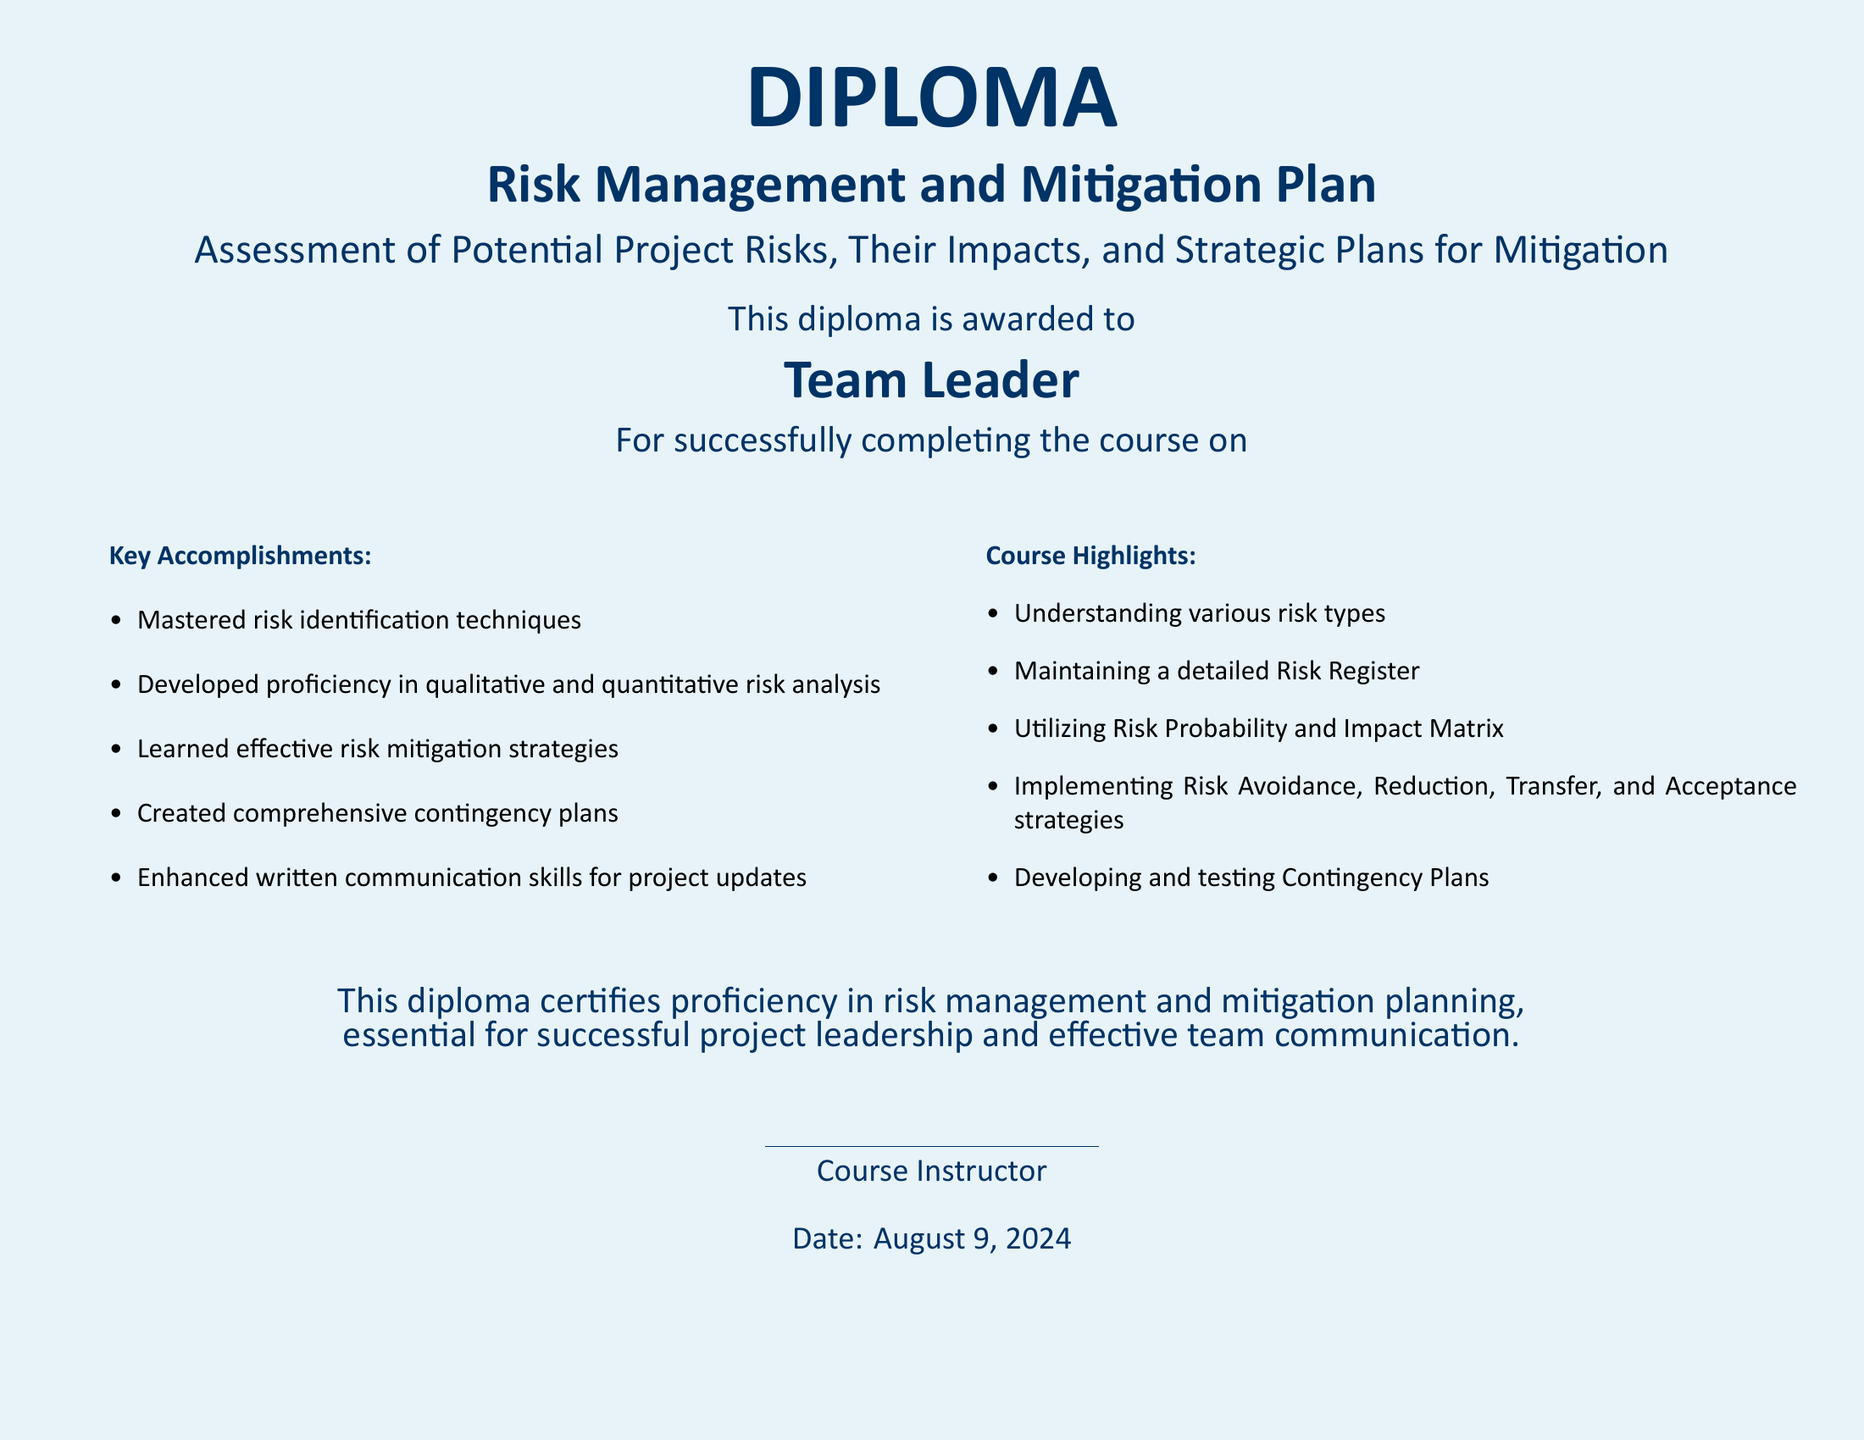What is the title of the diploma? The title of the diploma is stated prominently at the top of the document as "Risk Management and Mitigation Plan."
Answer: Risk Management and Mitigation Plan Who is the diploma awarded to? The diploma specifies that it is awarded to "Team Leader."
Answer: Team Leader What are the key accomplishments mentioned in the document? The document lists specific achievements under "Key Accomplishments," one of which is the mastery of risk identification techniques.
Answer: Mastered risk identification techniques What type of plans did they learn to create? The course highlights the creation of "comprehensive contingency plans."
Answer: Comprehensive contingency plans What date is stated at the bottom of the diploma? The date at the bottom of the diploma is indicated as "today," referring to the current date at the time of award.
Answer: Today What is one strategy mentioned for risk management in the course highlights? One of the strategies mentioned in the course highlights is "Risk Avoidance."
Answer: Risk Avoidance What color is the background of the diploma? The document describes the background color as "light blue!"
Answer: Light blue Which skills were enhanced through the course? The document states that written communication skills for project updates were enhanced.
Answer: Written communication skills for project updates 